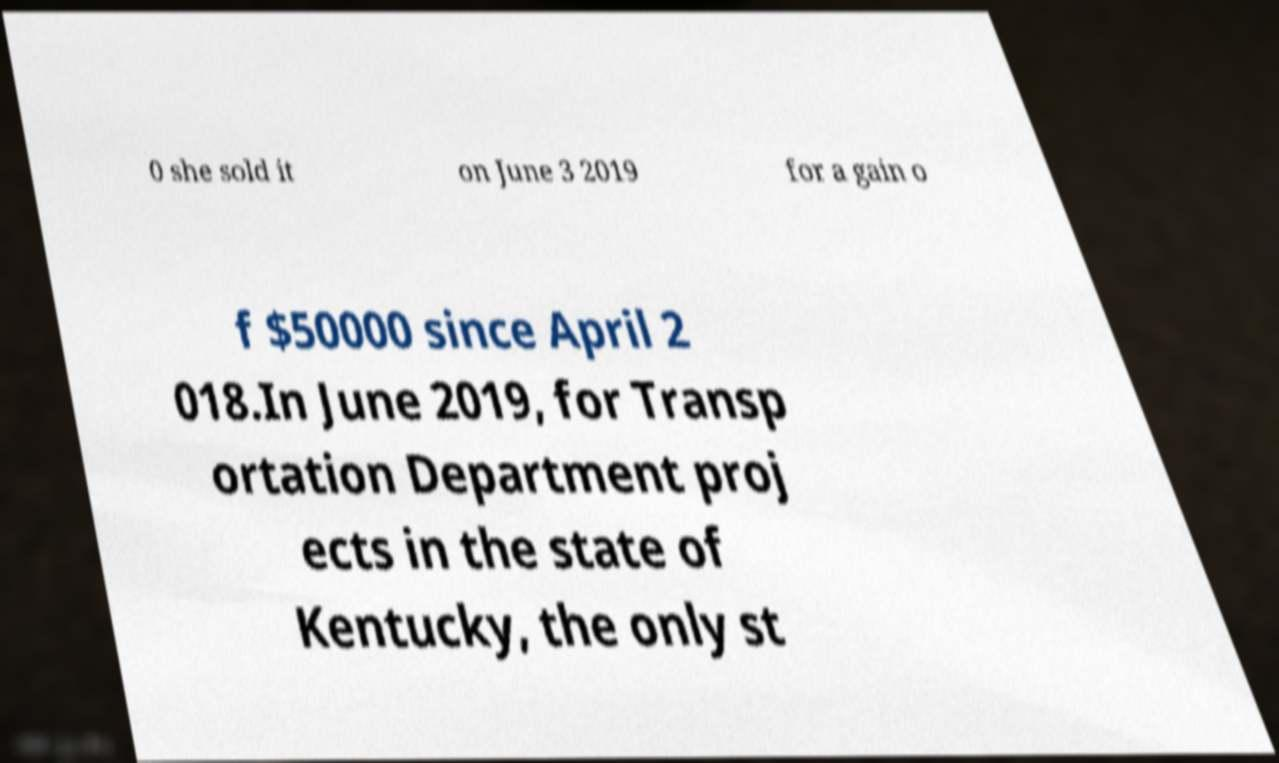Please read and relay the text visible in this image. What does it say? 0 she sold it on June 3 2019 for a gain o f $50000 since April 2 018.In June 2019, for Transp ortation Department proj ects in the state of Kentucky, the only st 